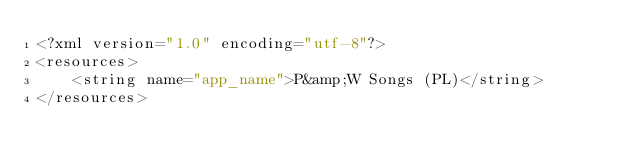Convert code to text. <code><loc_0><loc_0><loc_500><loc_500><_XML_><?xml version="1.0" encoding="utf-8"?>
<resources>
    <string name="app_name">P&amp;W Songs (PL)</string>
</resources>
</code> 